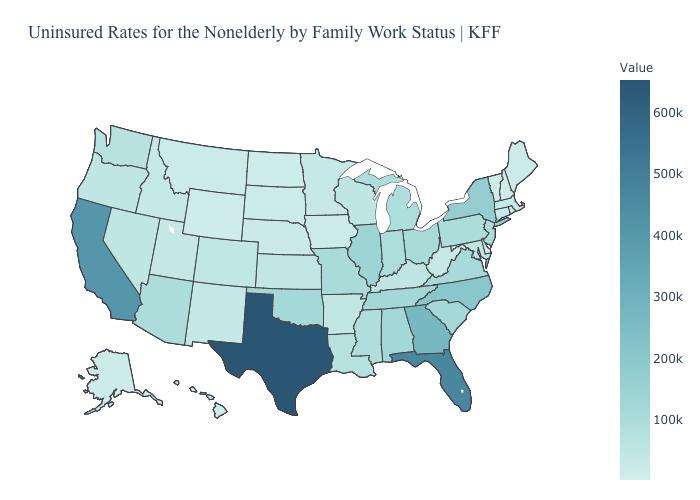Which states have the lowest value in the USA?
Quick response, please. Vermont. Among the states that border Iowa , does South Dakota have the lowest value?
Quick response, please. Yes. Does Delaware have the lowest value in the South?
Answer briefly. Yes. Which states have the lowest value in the West?
Short answer required. Wyoming. 